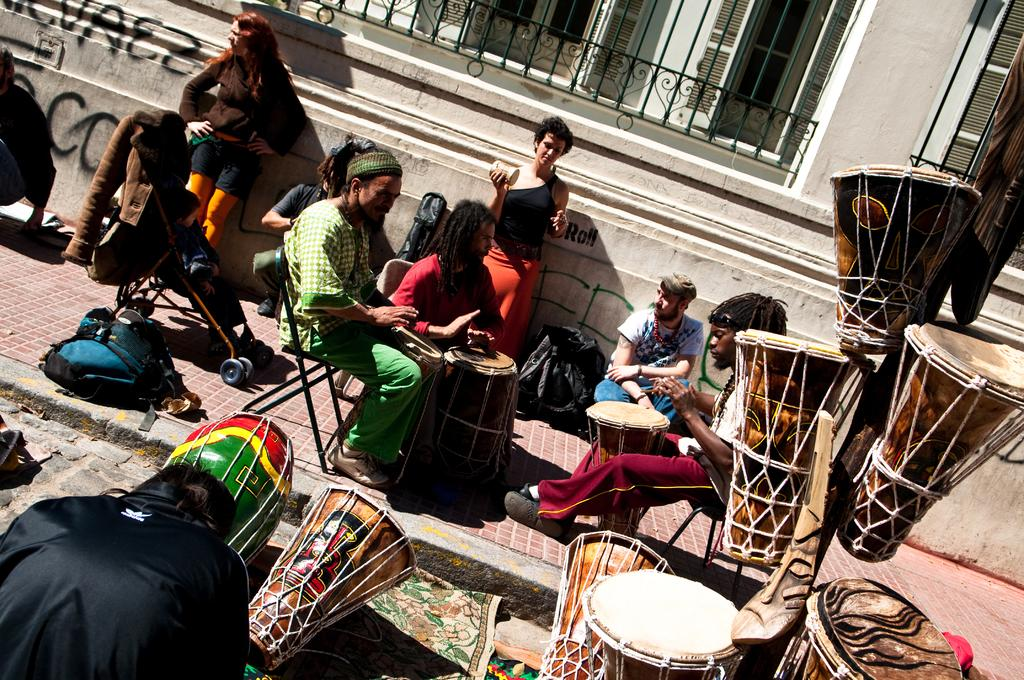How many people are sitting in chairs in the image? There are three persons sitting in chairs in the image. What are the people in the chairs doing? The persons are playing tabla. Are there any other people present in the image besides the tabla players? Yes, there are additional persons beside the tabla players. Where are the tablas located in the image? The tablas are in the right corner of the image. Can you see any toys or nests in the image? No, there are no toys or nests present in the image. How does the swim affect the tabla players in the image? There is no swim or swimming activity depicted in the image, so it does not affect the tabla players. 